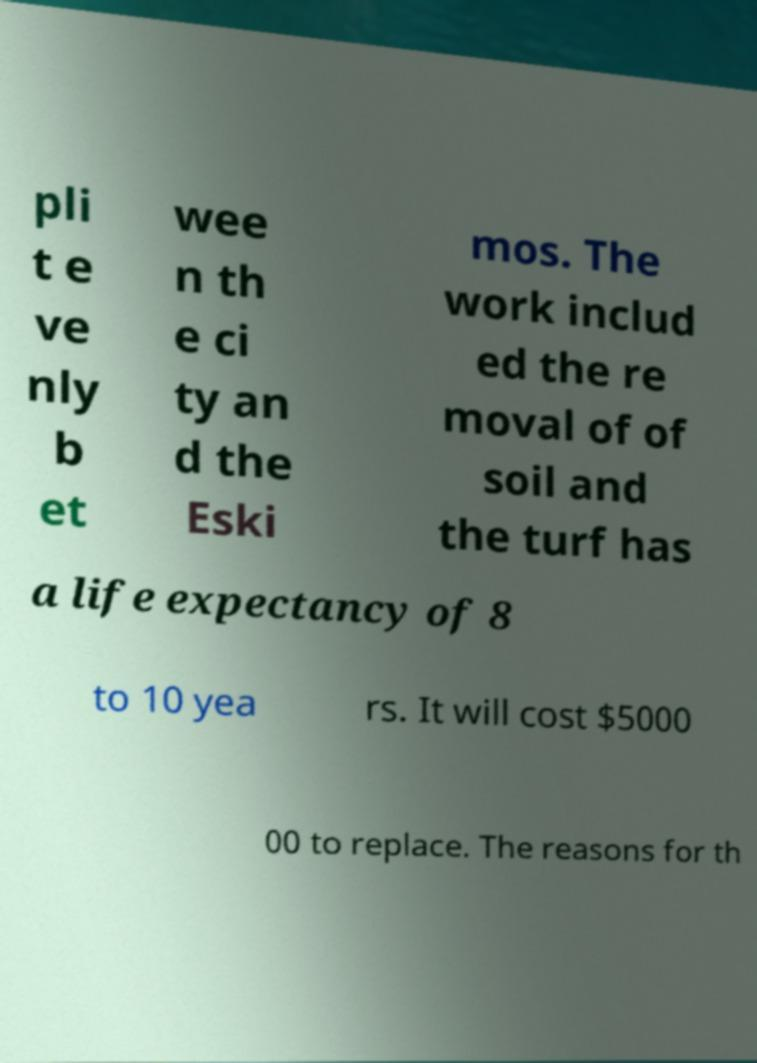Can you read and provide the text displayed in the image?This photo seems to have some interesting text. Can you extract and type it out for me? pli t e ve nly b et wee n th e ci ty an d the Eski mos. The work includ ed the re moval of of soil and the turf has a life expectancy of 8 to 10 yea rs. It will cost $5000 00 to replace. The reasons for th 